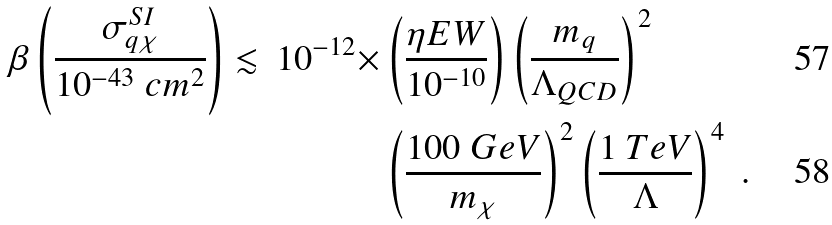<formula> <loc_0><loc_0><loc_500><loc_500>\beta \left ( \frac { \sigma ^ { S I } _ { q \chi } } { 1 0 ^ { - 4 3 } \ c m ^ { 2 } } \right ) \lesssim \, 1 0 ^ { - 1 2 } \times & \left ( \frac { \eta E W } { 1 0 ^ { - 1 0 } } \right ) \left ( \frac { m _ { q } } { \Lambda _ { Q C D } } \right ) ^ { 2 } \\ & \left ( \frac { 1 0 0 \ G e V } { m _ { \chi } } \right ) ^ { 2 } \left ( \frac { 1 \ T e V } { \Lambda } \right ) ^ { 4 } \ .</formula> 